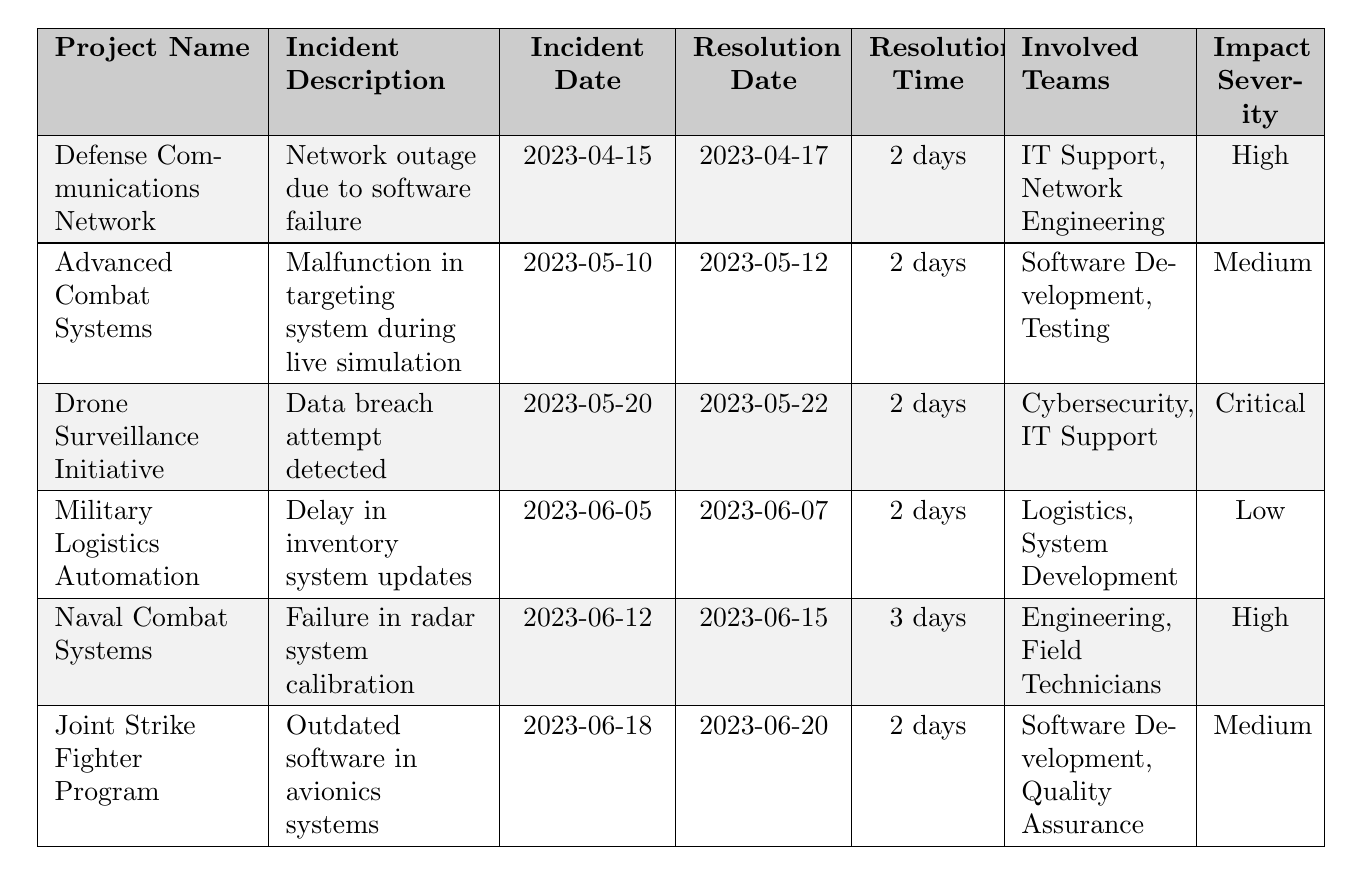What is the incident date for the "Drone Surveillance Initiative"? The table lists "Drone Surveillance Initiative" under the "Project Name" column, and the corresponding "Incident Date" column shows the date as 2023-05-20.
Answer: 2023-05-20 How many days did it take to resolve the incident for the "Naval Combat Systems"? For the "Naval Combat Systems," the "Resolution Time" column indicates it took 3 days to resolve the incident.
Answer: 3 days Which incident had the highest impact severity? The incident with the highest impact severity listed in the table is from the "Drone Surveillance Initiative," where the severity is classified as "Critical."
Answer: Critical What is the total number of incidents reported across all projects? Counting each entry in the table, there are a total of 6 incidents reported across the different projects.
Answer: 6 How many teams were involved in the incident for the "Military Logistics Automation"? The "Military Logistics Automation" incident involved two teams: "Logistics" and "System Development." Thus, the count of involved teams is 2.
Answer: 2 Which project had a longer resolution time, "Defense Communications Network" or "Joint Strike Fighter Program"? For "Defense Communications Network," the resolution time is 2 days, while for "Joint Strike Fighter Program," the resolution time is also 2 days. Comparing both, they have identical resolution times.
Answer: Both have 2 days Is there any incident with a resolution time of more than 2 days? Yes, there is an incident listed under "Naval Combat Systems" with a resolution time of 3 days, indicating that it exceeds 2 days.
Answer: Yes What percentage of the incidents had high or critical impact severity? There are 3 incidents classified as high or critical (2 high and 1 critical) out of 6 total incidents. To find the percentage: (3/6) * 100 = 50%.
Answer: 50% What is the average resolution time across all incidents? The resolution times are 2, 2, 2, 2, 3, and 2 days. Adding them gives 13 days. There are 6 incidents, so to find the average: 13/6 = approximately 2.17 days.
Answer: Approximately 2.17 days In which project did the incident occur on May 10 and what was the severity? The incident on May 10 is related to the "Advanced Combat Systems," and it has an impact severity classified as "Medium."
Answer: Advanced Combat Systems, Medium How many days did it take to resolve the incident related to the "Drone Surveillance Initiative"? The resolution time for the "Drone Surveillance Initiative" is noted as 2 days in the table.
Answer: 2 days 